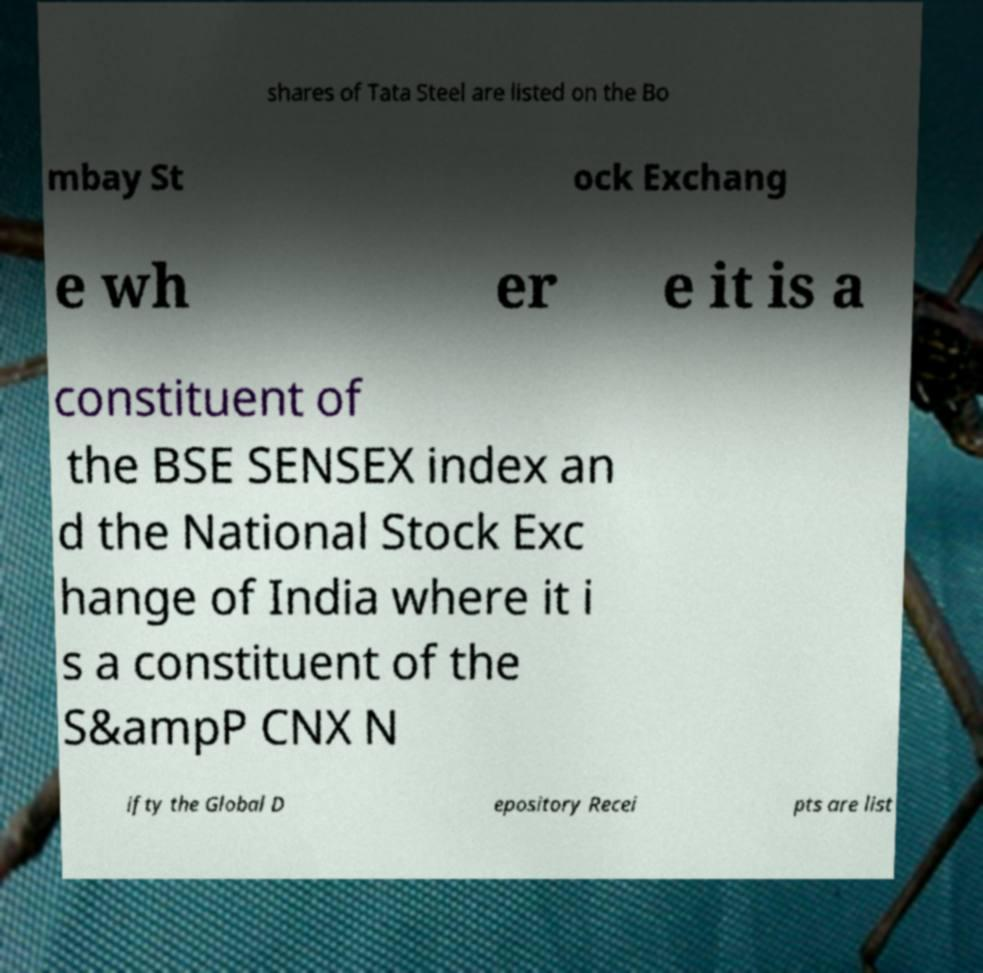Can you read and provide the text displayed in the image?This photo seems to have some interesting text. Can you extract and type it out for me? shares of Tata Steel are listed on the Bo mbay St ock Exchang e wh er e it is a constituent of the BSE SENSEX index an d the National Stock Exc hange of India where it i s a constituent of the S&ampP CNX N ifty the Global D epository Recei pts are list 